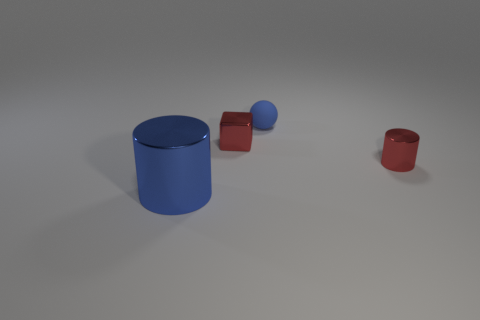How many objects are shiny objects right of the blue cylinder or purple cylinders?
Ensure brevity in your answer.  2. Do the large cylinder and the small metal thing that is right of the cube have the same color?
Provide a succinct answer. No. Are there any blue cylinders of the same size as the blue rubber ball?
Keep it short and to the point. No. The blue thing in front of the blue thing behind the blue cylinder is made of what material?
Offer a terse response. Metal. How many cylinders have the same color as the tiny metallic cube?
Your answer should be very brief. 1. What is the shape of the large object that is the same material as the small cube?
Offer a terse response. Cylinder. How big is the shiny cylinder that is to the right of the big metallic cylinder?
Give a very brief answer. Small. Are there an equal number of small matte objects in front of the tiny blue rubber ball and cubes that are left of the big shiny cylinder?
Ensure brevity in your answer.  Yes. There is a cylinder behind the blue thing in front of the shiny cylinder that is right of the metal cube; what color is it?
Offer a terse response. Red. What number of small shiny objects are right of the tiny blue object and on the left side of the red shiny cylinder?
Offer a very short reply. 0. 